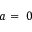<formula> <loc_0><loc_0><loc_500><loc_500>a = 0</formula> 